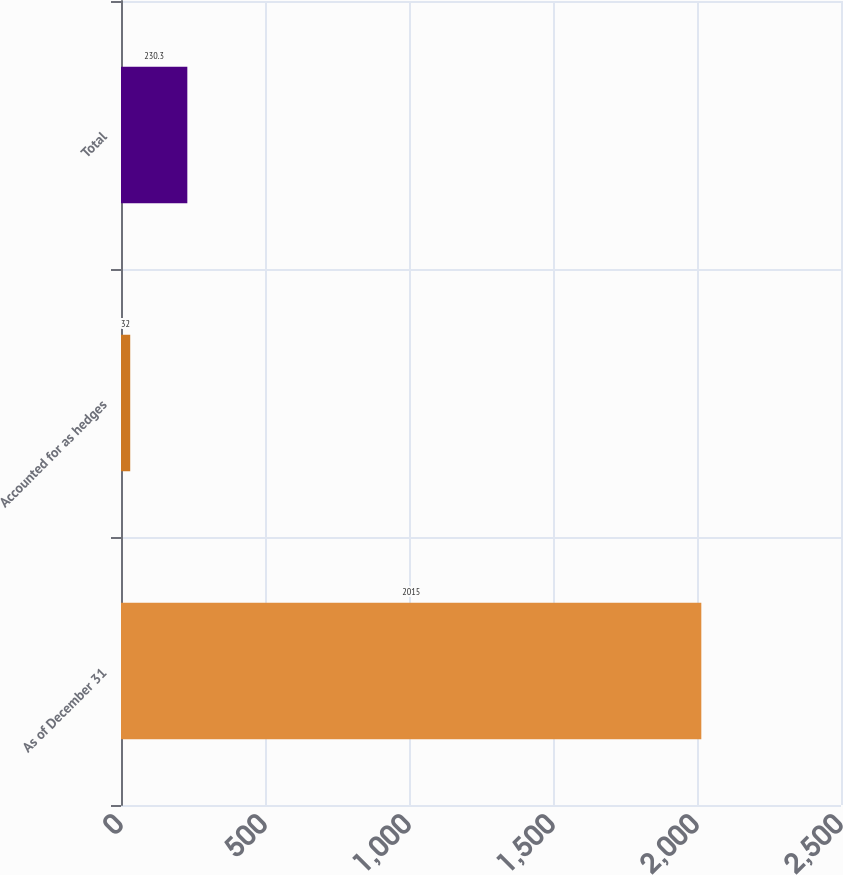Convert chart to OTSL. <chart><loc_0><loc_0><loc_500><loc_500><bar_chart><fcel>As of December 31<fcel>Accounted for as hedges<fcel>Total<nl><fcel>2015<fcel>32<fcel>230.3<nl></chart> 